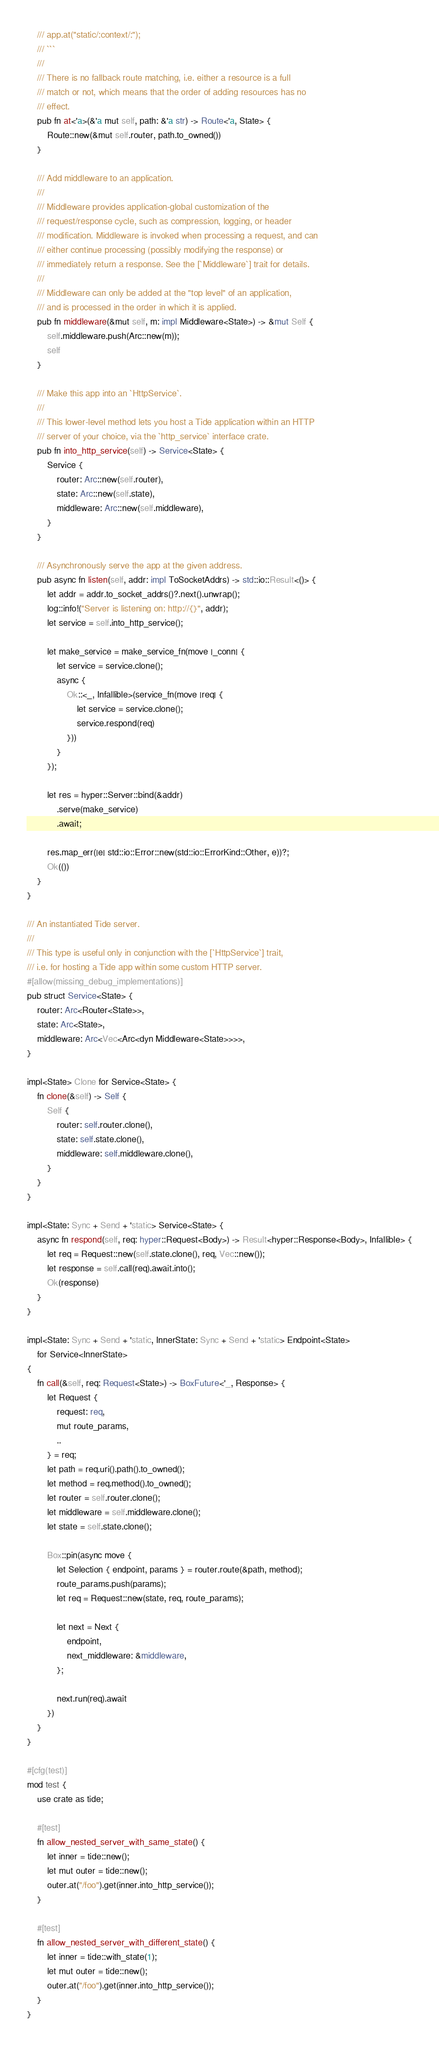<code> <loc_0><loc_0><loc_500><loc_500><_Rust_>    /// app.at("static/:context/:");
    /// ```
    ///
    /// There is no fallback route matching, i.e. either a resource is a full
    /// match or not, which means that the order of adding resources has no
    /// effect.
    pub fn at<'a>(&'a mut self, path: &'a str) -> Route<'a, State> {
        Route::new(&mut self.router, path.to_owned())
    }

    /// Add middleware to an application.
    ///
    /// Middleware provides application-global customization of the
    /// request/response cycle, such as compression, logging, or header
    /// modification. Middleware is invoked when processing a request, and can
    /// either continue processing (possibly modifying the response) or
    /// immediately return a response. See the [`Middleware`] trait for details.
    ///
    /// Middleware can only be added at the "top level" of an application,
    /// and is processed in the order in which it is applied.
    pub fn middleware(&mut self, m: impl Middleware<State>) -> &mut Self {
        self.middleware.push(Arc::new(m));
        self
    }

    /// Make this app into an `HttpService`.
    ///
    /// This lower-level method lets you host a Tide application within an HTTP
    /// server of your choice, via the `http_service` interface crate.
    pub fn into_http_service(self) -> Service<State> {
        Service {
            router: Arc::new(self.router),
            state: Arc::new(self.state),
            middleware: Arc::new(self.middleware),
        }
    }

    /// Asynchronously serve the app at the given address.
    pub async fn listen(self, addr: impl ToSocketAddrs) -> std::io::Result<()> {
        let addr = addr.to_socket_addrs()?.next().unwrap();
        log::info!("Server is listening on: http://{}", addr);
        let service = self.into_http_service();

        let make_service = make_service_fn(move |_conn| {
            let service = service.clone();
            async {
                Ok::<_, Infallible>(service_fn(move |req| {
                    let service = service.clone();
                    service.respond(req)
                }))
            }
        });

        let res = hyper::Server::bind(&addr)
            .serve(make_service)
            .await;

        res.map_err(|e| std::io::Error::new(std::io::ErrorKind::Other, e))?;
        Ok(())
    }
}

/// An instantiated Tide server.
///
/// This type is useful only in conjunction with the [`HttpService`] trait,
/// i.e. for hosting a Tide app within some custom HTTP server.
#[allow(missing_debug_implementations)]
pub struct Service<State> {
    router: Arc<Router<State>>,
    state: Arc<State>,
    middleware: Arc<Vec<Arc<dyn Middleware<State>>>>,
}

impl<State> Clone for Service<State> {
    fn clone(&self) -> Self {
        Self {
            router: self.router.clone(),
            state: self.state.clone(),
            middleware: self.middleware.clone(),
        }
    }
}

impl<State: Sync + Send + 'static> Service<State> {
    async fn respond(self, req: hyper::Request<Body>) -> Result<hyper::Response<Body>, Infallible> {
        let req = Request::new(self.state.clone(), req, Vec::new());
        let response = self.call(req).await.into();
        Ok(response)
    }
}

impl<State: Sync + Send + 'static, InnerState: Sync + Send + 'static> Endpoint<State>
    for Service<InnerState>
{
    fn call(&self, req: Request<State>) -> BoxFuture<'_, Response> {
        let Request {
            request: req,
            mut route_params,
            ..
        } = req;
        let path = req.uri().path().to_owned();
        let method = req.method().to_owned();
        let router = self.router.clone();
        let middleware = self.middleware.clone();
        let state = self.state.clone();

        Box::pin(async move {
            let Selection { endpoint, params } = router.route(&path, method);
            route_params.push(params);
            let req = Request::new(state, req, route_params);

            let next = Next {
                endpoint,
                next_middleware: &middleware,
            };

            next.run(req).await
        })
    }
}

#[cfg(test)]
mod test {
    use crate as tide;

    #[test]
    fn allow_nested_server_with_same_state() {
        let inner = tide::new();
        let mut outer = tide::new();
        outer.at("/foo").get(inner.into_http_service());
    }

    #[test]
    fn allow_nested_server_with_different_state() {
        let inner = tide::with_state(1);
        let mut outer = tide::new();
        outer.at("/foo").get(inner.into_http_service());
    }
}
</code> 